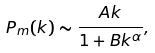Convert formula to latex. <formula><loc_0><loc_0><loc_500><loc_500>P _ { m } ( k ) \sim \frac { A k } { 1 + B k ^ { \alpha } } ,</formula> 